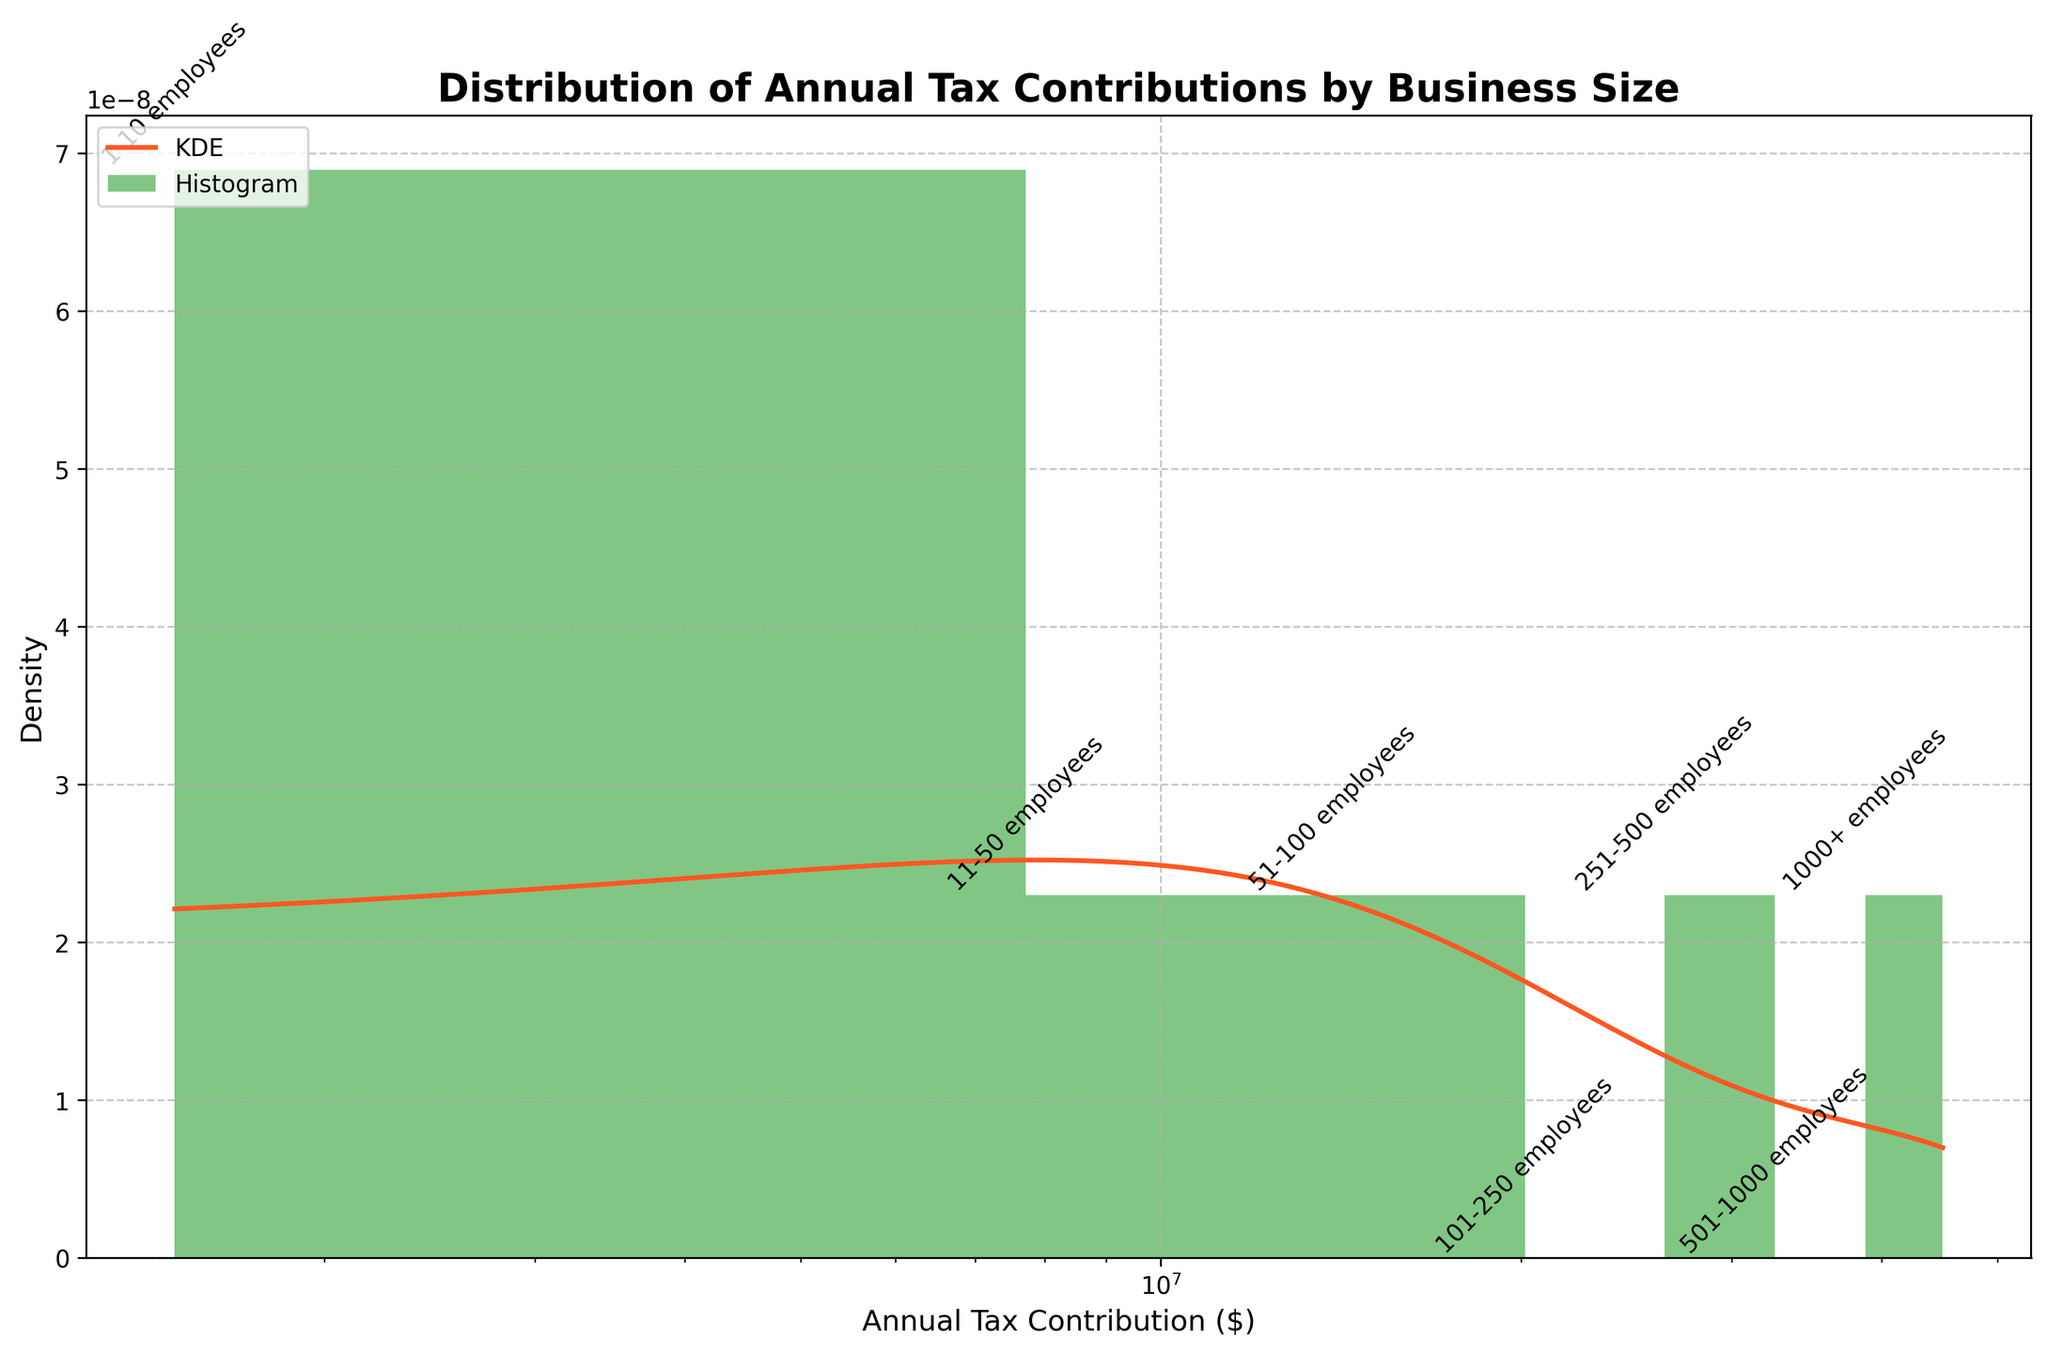What is the title of the plot? The title is usually located at the top of the plot and provides a summary of what the data represents. In this case, it reads "Distribution of Annual Tax Contributions by Business Size".
Answer: Distribution of Annual Tax Contributions by Business Size How many bins are in the histogram? Bins in a histogram represent the intervals into which the data is divided. By observing the x-axis and the bars, we can count the number of bins used.
Answer: 7 Which business size category is associated with the highest tax contribution? The business size with the highest tax contribution can be identified by looking at the annotations inside or directly above the tallest bars.
Answer: 1000+ employees Is the x-axis of the plot linear or logarithmic? The x-axis scale is observed by noting whether the axis labels increase linearly or exponentially. Here, it increases exponentially.
Answer: Logarithmic What is the density value of the KDE peak? The KDE peak value is identified by looking at the highest point of the red density curve. This represents where the most data points are concentrated.
Answer: Around 3.5 Which business size category contributes about $15,000,000 in taxes annually? This can be identified by finding the bar associated with the tax contribution of $15,000,000 and noting the annotation above it.
Answer: 251-500 employees How does the tax contribution trend change as business sizes increase? By observing the histogram bars and the KDE, we can see how the bar heights change from left (smaller businesses) to right (larger businesses). As business sizes increase, both the bar heights and the KDE peak values generally increase, indicating higher contributions.
Answer: Increases Compare the density of annual tax contributions between small-sized businesses (1-10 employees) and large-sized businesses (1000+ employees). Small businesses have a higher number of businesses but a lower overall tax contribution density (shorter bar), while large businesses have a significantly higher tax contribution density (taller bar). The KDE curve also shows a higher peak at larger tax contributions.
Answer: Larger businesses have higher density What is the range of annual tax contributions covered in the plot? By checking the x-axis from the smallest to the largest value shown, the range can be identified. It spans from the minimum to the maximum tax contributions plotted.
Answer: $1,500,000 to $45,000,000 